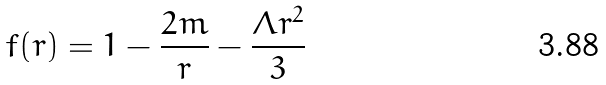Convert formula to latex. <formula><loc_0><loc_0><loc_500><loc_500>f ( r ) = 1 - \frac { 2 m } { r } - \frac { \Lambda r ^ { 2 } } { 3 }</formula> 